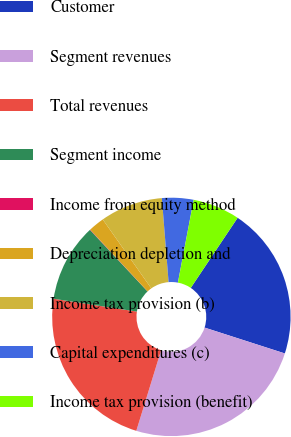<chart> <loc_0><loc_0><loc_500><loc_500><pie_chart><fcel>Customer<fcel>Segment revenues<fcel>Total revenues<fcel>Segment income<fcel>Income from equity method<fcel>Depreciation depletion and<fcel>Income tax provision (b)<fcel>Capital expenditures (c)<fcel>Income tax provision (benefit)<nl><fcel>20.58%<fcel>24.79%<fcel>22.68%<fcel>10.59%<fcel>0.05%<fcel>2.16%<fcel>8.49%<fcel>4.27%<fcel>6.38%<nl></chart> 